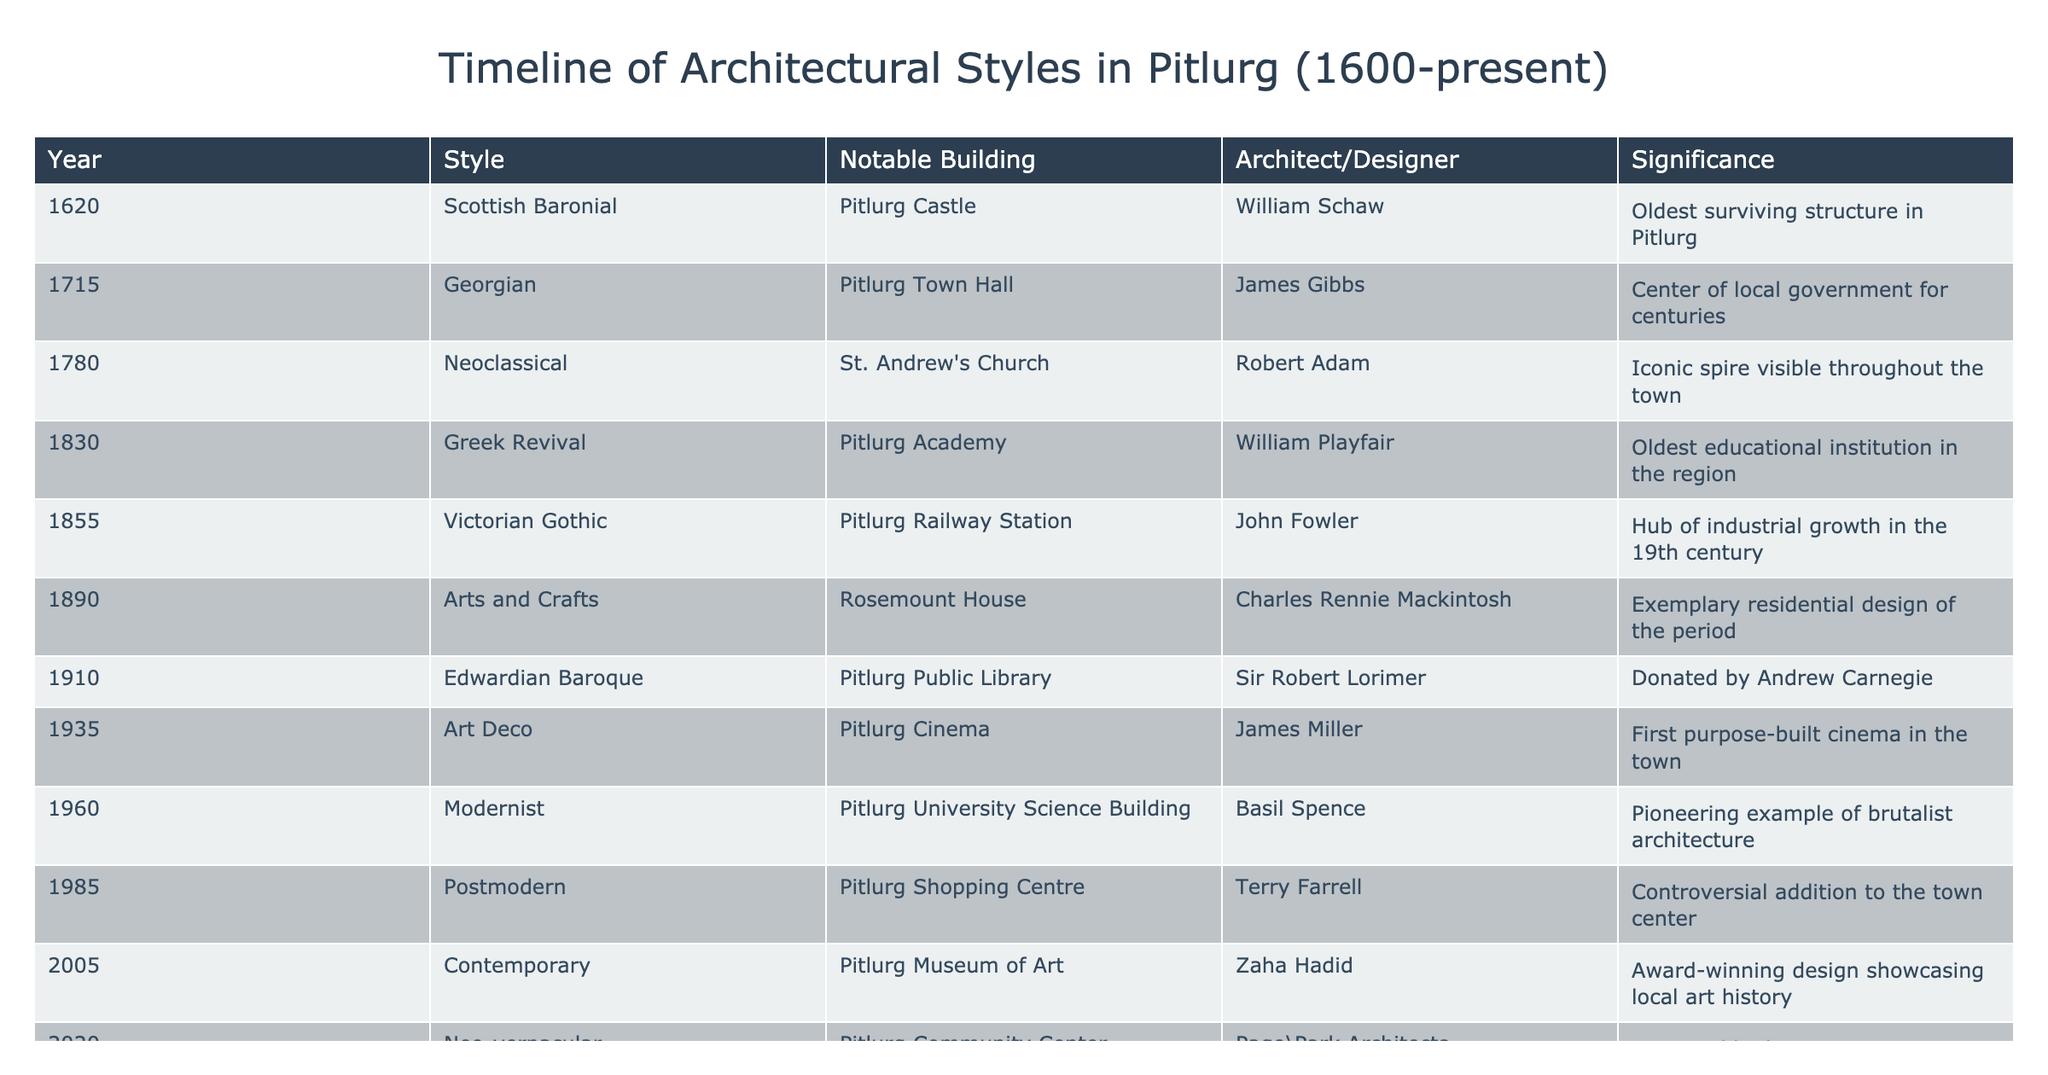What is the oldest surviving structure in Pitlurg? According to the table, the oldest surviving structure in Pitlurg is Pitlurg Castle, which was built in 1620 in the Scottish Baronial style.
Answer: Pitlurg Castle Which architectural style is represented by Pitlurg Town Hall? The table specifies that Pitlurg Town Hall, constructed in 1715, is in the Georgian style.
Answer: Georgian How many years elapsed between the construction of Pitlurg Academy and the Pitlurg Community Center? Pitlurg Academy was built in 1830 and the Pitlurg Community Center was completed in 2020. Thus, the elapsed time is 2020 - 1830 = 190 years.
Answer: 190 years Is it true that there is a building in Pitlurg designed by Zaha Hadid? The table indicates that the Pitlurg Museum of Art, designed by Zaha Hadid in 2005, is included. Therefore, the statement is true.
Answer: Yes Which notable building was designed by Charles Rennie Mackintosh? From the table, Rosemount House is cited as being designed by Charles Rennie Mackintosh in 1890.
Answer: Rosemount House What is the average year of construction for the buildings listed in the 19th century? The table lists three buildings from the 19th century: Pitlurg Academy (1830), Pitlurg Railway Station (1855), and Rosemount House (1890). Their average year is calculated as (1830 + 1855 + 1890) / 3 = 1858.33, which we round to 1858.
Answer: 1858 Which style marked the transition from Victorian Gothic to the modern styles in Pitlurg's architecture? The transition can be traced from Victorian Gothic (1855) to Modernist (1960). Therefore, the style that marked this transition is Modernist.
Answer: Modernist How many buildings were constructed in the 20th century in Pitlurg, according to the table? The table shows three buildings from the 20th century: Pitlurg Public Library (1910), Pitlurg Cinema (1935), and Pitlurg Museum of Art (2005). Therefore, the number of buildings is 3.
Answer: 3 Was any architectural style represented by a building that served as a hub of industrial growth in Pitlurg? The table states that the Pitlurg Railway Station, designed in the Victorian Gothic style, served as the hub of industrial growth in the 19th century. Therefore, the statement is true.
Answer: Yes 